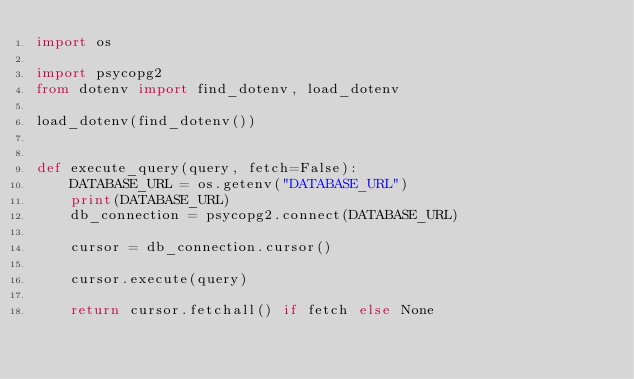Convert code to text. <code><loc_0><loc_0><loc_500><loc_500><_Python_>import os

import psycopg2
from dotenv import find_dotenv, load_dotenv

load_dotenv(find_dotenv())


def execute_query(query, fetch=False):
    DATABASE_URL = os.getenv("DATABASE_URL")
    print(DATABASE_URL)
    db_connection = psycopg2.connect(DATABASE_URL)

    cursor = db_connection.cursor()

    cursor.execute(query)

    return cursor.fetchall() if fetch else None
</code> 